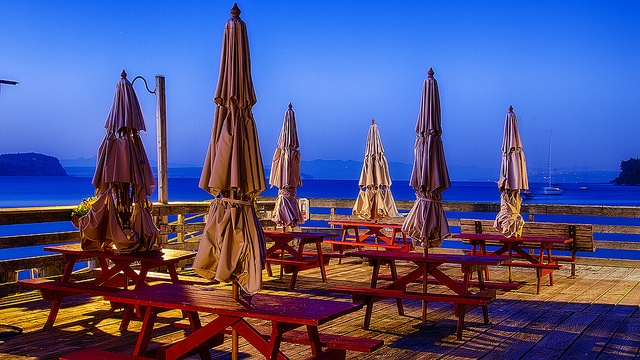Describe the objects in this image and their specific colors. I can see umbrella in blue, black, maroon, and brown tones, bench in blue, maroon, black, and purple tones, umbrella in blue, maroon, black, and purple tones, dining table in blue, maroon, black, and purple tones, and umbrella in blue, black, maroon, and purple tones in this image. 